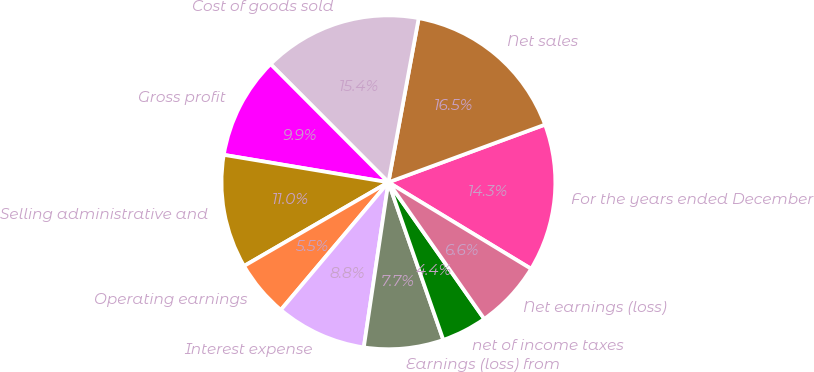Convert chart to OTSL. <chart><loc_0><loc_0><loc_500><loc_500><pie_chart><fcel>For the years ended December<fcel>Net sales<fcel>Cost of goods sold<fcel>Gross profit<fcel>Selling administrative and<fcel>Operating earnings<fcel>Interest expense<fcel>Earnings (loss) from<fcel>net of income taxes<fcel>Net earnings (loss)<nl><fcel>14.29%<fcel>16.48%<fcel>15.38%<fcel>9.89%<fcel>10.99%<fcel>5.49%<fcel>8.79%<fcel>7.69%<fcel>4.4%<fcel>6.59%<nl></chart> 